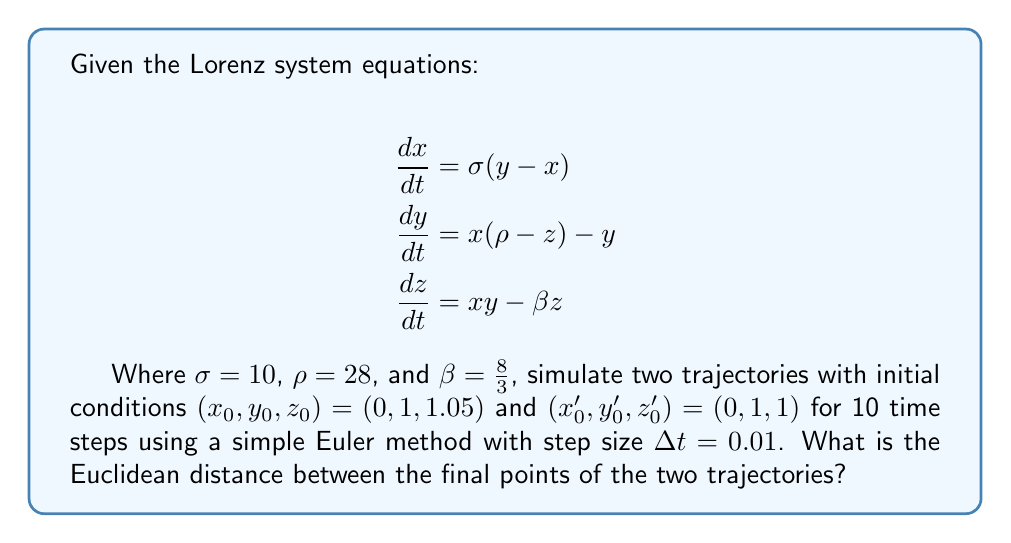Can you solve this math problem? To solve this problem, we'll follow these steps:

1. Implement the Euler method for the Lorenz system
2. Simulate both trajectories for 10 time steps
3. Calculate the Euclidean distance between the final points

Step 1: Implement the Euler method

The Euler method for a system of differential equations is given by:

$$x_{n+1} = x_n + \Delta t \cdot f(x_n, y_n, z_n)$$
$$y_{n+1} = y_n + \Delta t \cdot g(x_n, y_n, z_n)$$
$$z_{n+1} = z_n + \Delta t \cdot h(x_n, y_n, z_n)$$

Where $f$, $g$, and $h$ are the right-hand sides of the Lorenz equations.

Step 2: Simulate both trajectories

Let's simulate both trajectories using a simple loop in pseudocode:

```
for i = 1 to 10:
    x = x + dt * sigma * (y - x)
    y = y + dt * (x * (rho - z) - y)
    z = z + dt * (x * y - beta * z)
```

Trajectory 1 (x, y, z):
(0, 1, 1.05) → (0.1, 1.28, 1.0492) → (0.2954, 1.5491, 1.0477) → ...
→ (1.4276, 1.9596, 1.3631)

Trajectory 2 (x', y', z'):
(0, 1, 1) → (0.1, 1.28, 0.9973) → (0.2955, 1.5492, 0.9940) → ...
→ (1.4291, 1.9618, 1.3092)

Step 3: Calculate the Euclidean distance

The Euclidean distance between two points $(x_1, y_1, z_1)$ and $(x_2, y_2, z_2)$ is given by:

$$d = \sqrt{(x_2 - x_1)^2 + (y_2 - y_1)^2 + (z_2 - z_1)^2}$$

Plugging in our final points:

$$d = \sqrt{(1.4291 - 1.4276)^2 + (1.9618 - 1.9596)^2 + (1.3092 - 1.3631)^2}$$
$$d = \sqrt{0.0015^2 + 0.0022^2 + (-0.0539)^2}$$
$$d \approx 0.0540$$

This result demonstrates the sensitivity to initial conditions in the Lorenz system, as a small change in the initial z-coordinate (0.05) led to a noticeable difference in the final positions after just 10 time steps.
Answer: 0.0540 